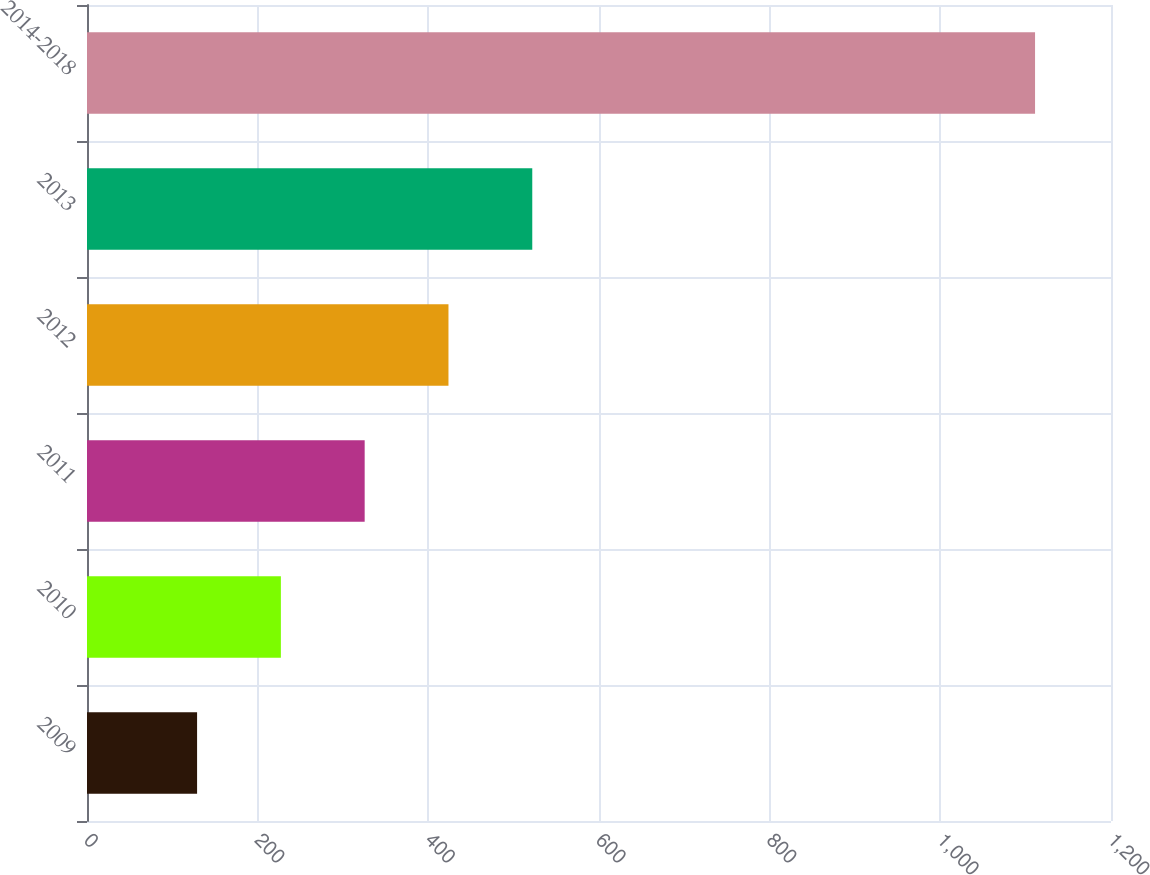Convert chart to OTSL. <chart><loc_0><loc_0><loc_500><loc_500><bar_chart><fcel>2009<fcel>2010<fcel>2011<fcel>2012<fcel>2013<fcel>2014-2018<nl><fcel>129<fcel>227.2<fcel>325.4<fcel>423.6<fcel>521.8<fcel>1111<nl></chart> 